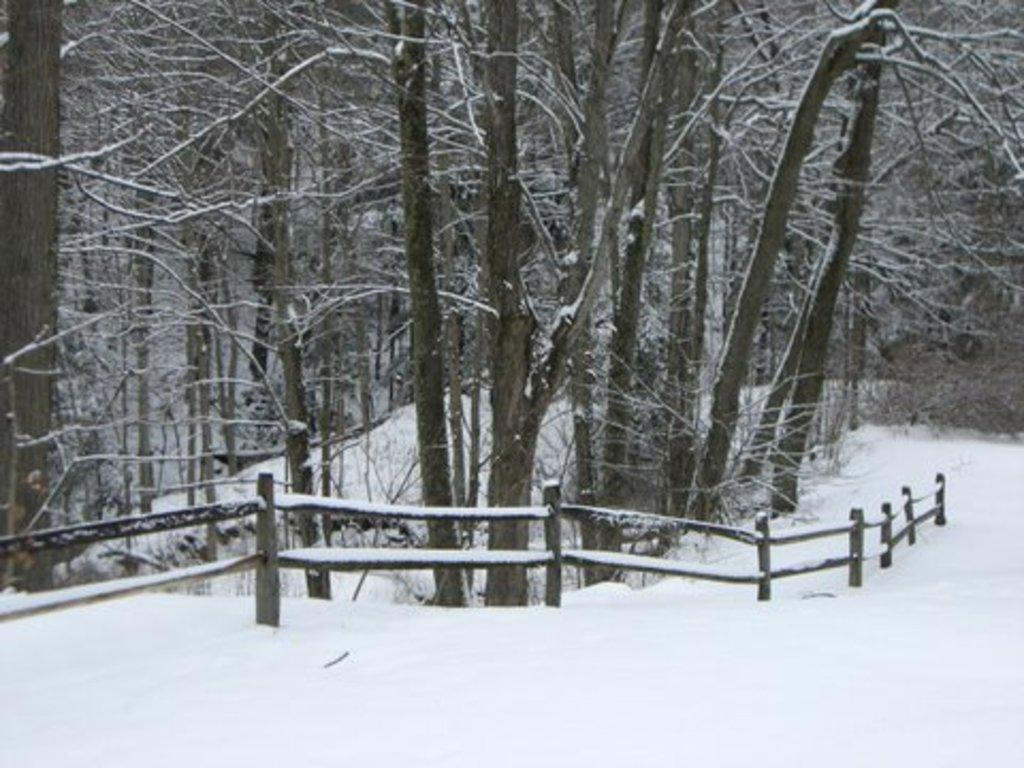What is the condition of the land in the image? The land in the image is covered with snow. What can be seen in the background of the image? There is a fencing and trees in the background of the image, and they are also covered with snow. What type of sugar is being used to decorate the geese in the image? There are no geese or sugar present in the image; it features a snow-covered landscape with a fencing and trees in the background. 